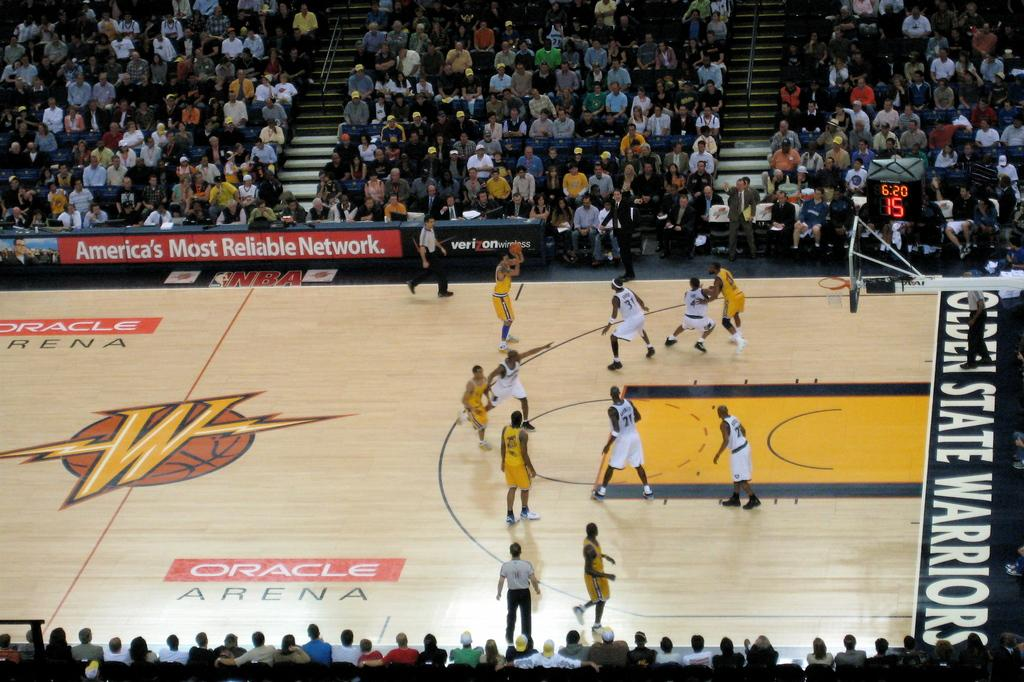<image>
Present a compact description of the photo's key features. The Golden State Warriors play a game at Oracle Arena. 